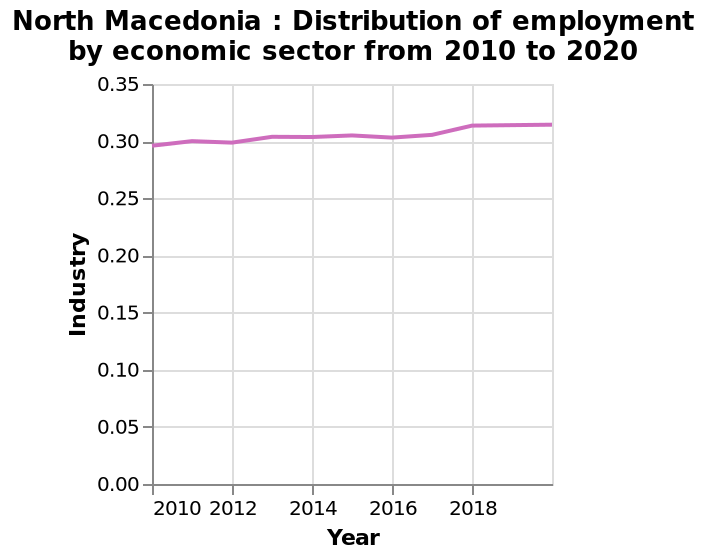<image>
Did industrial distribution in North Macedonia decline at any point?  No, there have been no times of decline in industrial distribution in North Macedonia. Has industrial distribution in North Macedonia been consistent over the years? Yes, industrial distribution in North Macedonia has been consistently increasing, with no times of decline. How is the x-axis measured in the line graph? The x-axis is measured using a linear scale that ranges from 2010 to 2018, representing the years. 